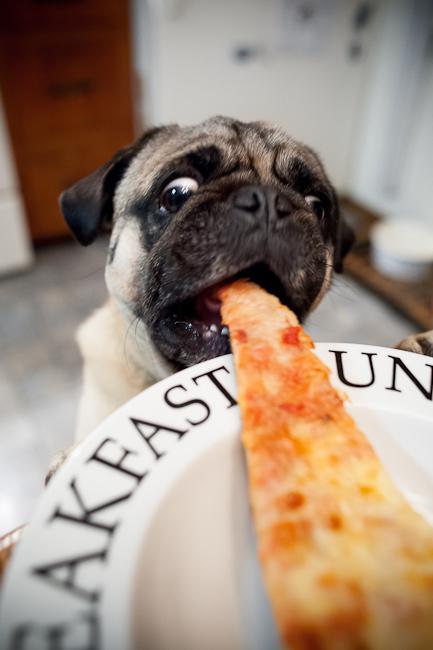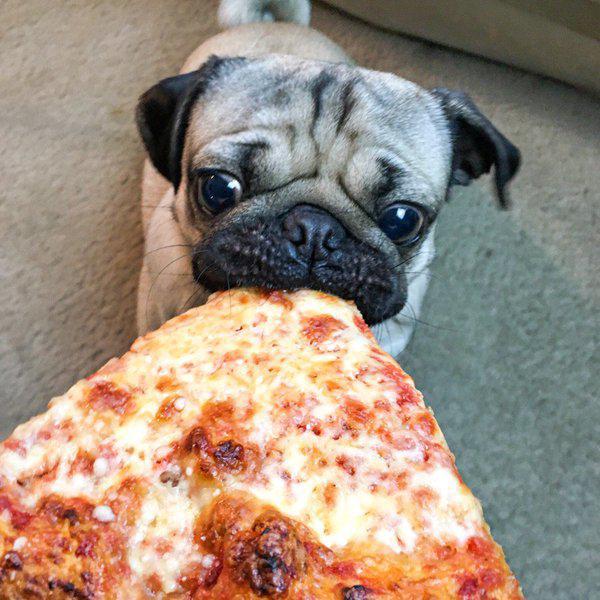The first image is the image on the left, the second image is the image on the right. Analyze the images presented: Is the assertion "A chubby beige pug is sitting in a container in one image, and the other image shows a pug with orange food in front of its mouth." valid? Answer yes or no. No. The first image is the image on the left, the second image is the image on the right. Evaluate the accuracy of this statement regarding the images: "A dog is eating a plain cheese pizza in at least one of the images.". Is it true? Answer yes or no. Yes. 